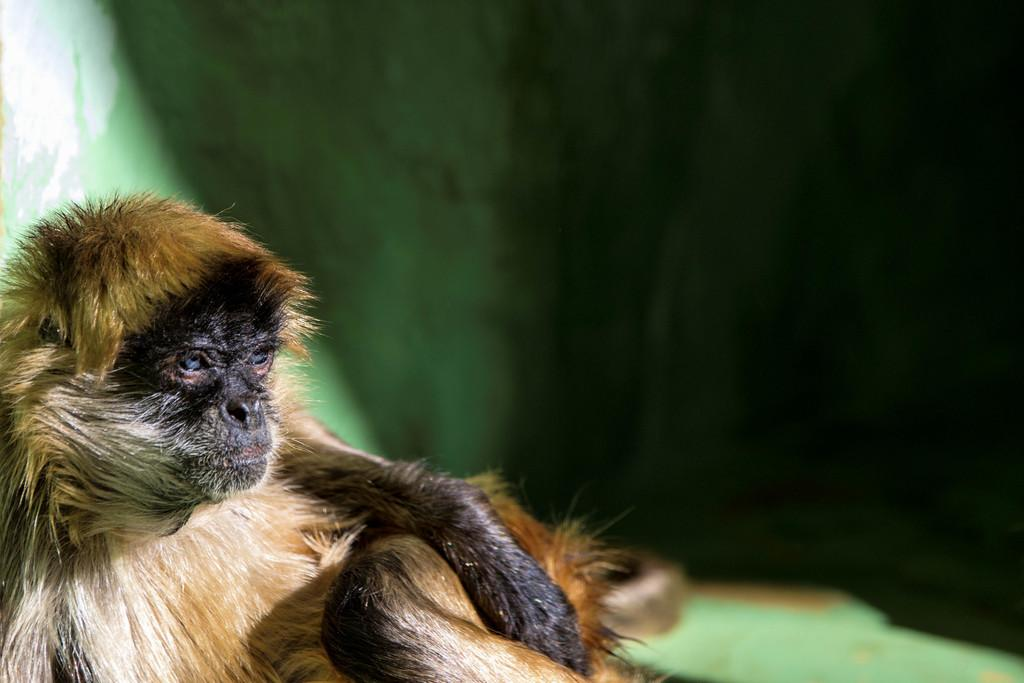What is the main subject in the front portion of the image? There is a monkey in the front portion of the image. Can you describe the background of the image? The background of the image is blurred. What type of hair can be seen on the lawyer's finger in the image? There is no lawyer or finger present in the image, and therefore no hair can be observed. 